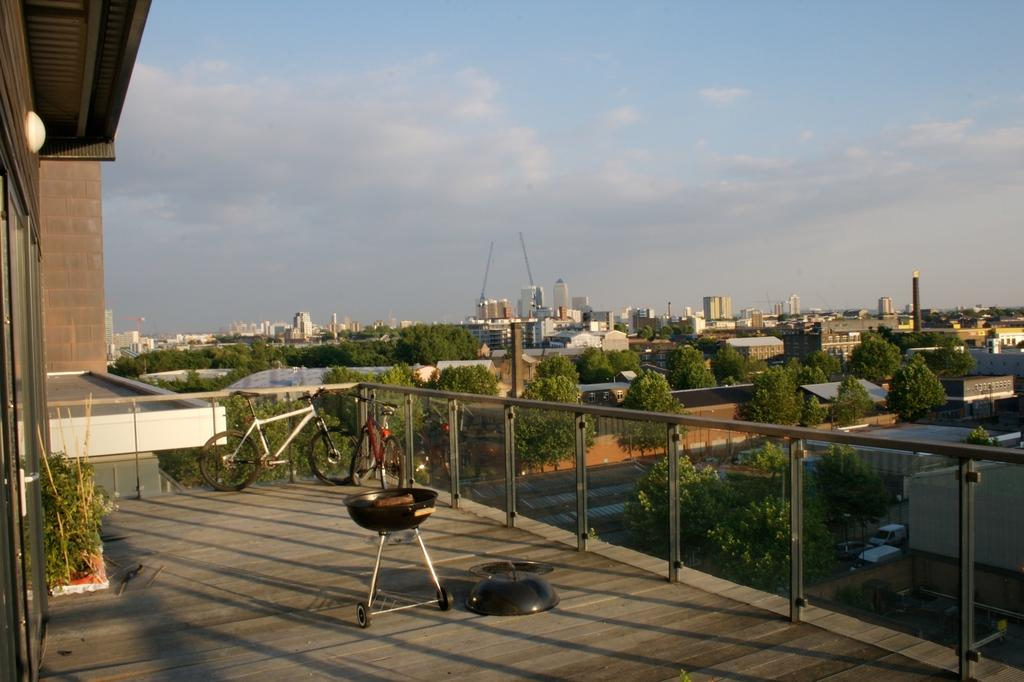How many bicycles are in the image? There are two bicycles in the image. What type of barrier is present in the image? There is a glass wall in the image. What can be seen in the background of the image? Trees, buildings, and poles are visible in the background of the image. What is the color of the trees in the image? The trees are green in color. What is the color scheme of the buildings in the image? The buildings are in cream and white colors. What is the color of the poles in the image? The color of the poles is not mentioned in the facts, so we cannot determine their color. What is visible in the sky in the image? The sky is visible in the image, and it is in white and blue colors. What type of skin condition can be seen on the bicycles in the image? There is no mention of skin conditions in the image, as it features bicycles, a glass wall, and various background elements. 